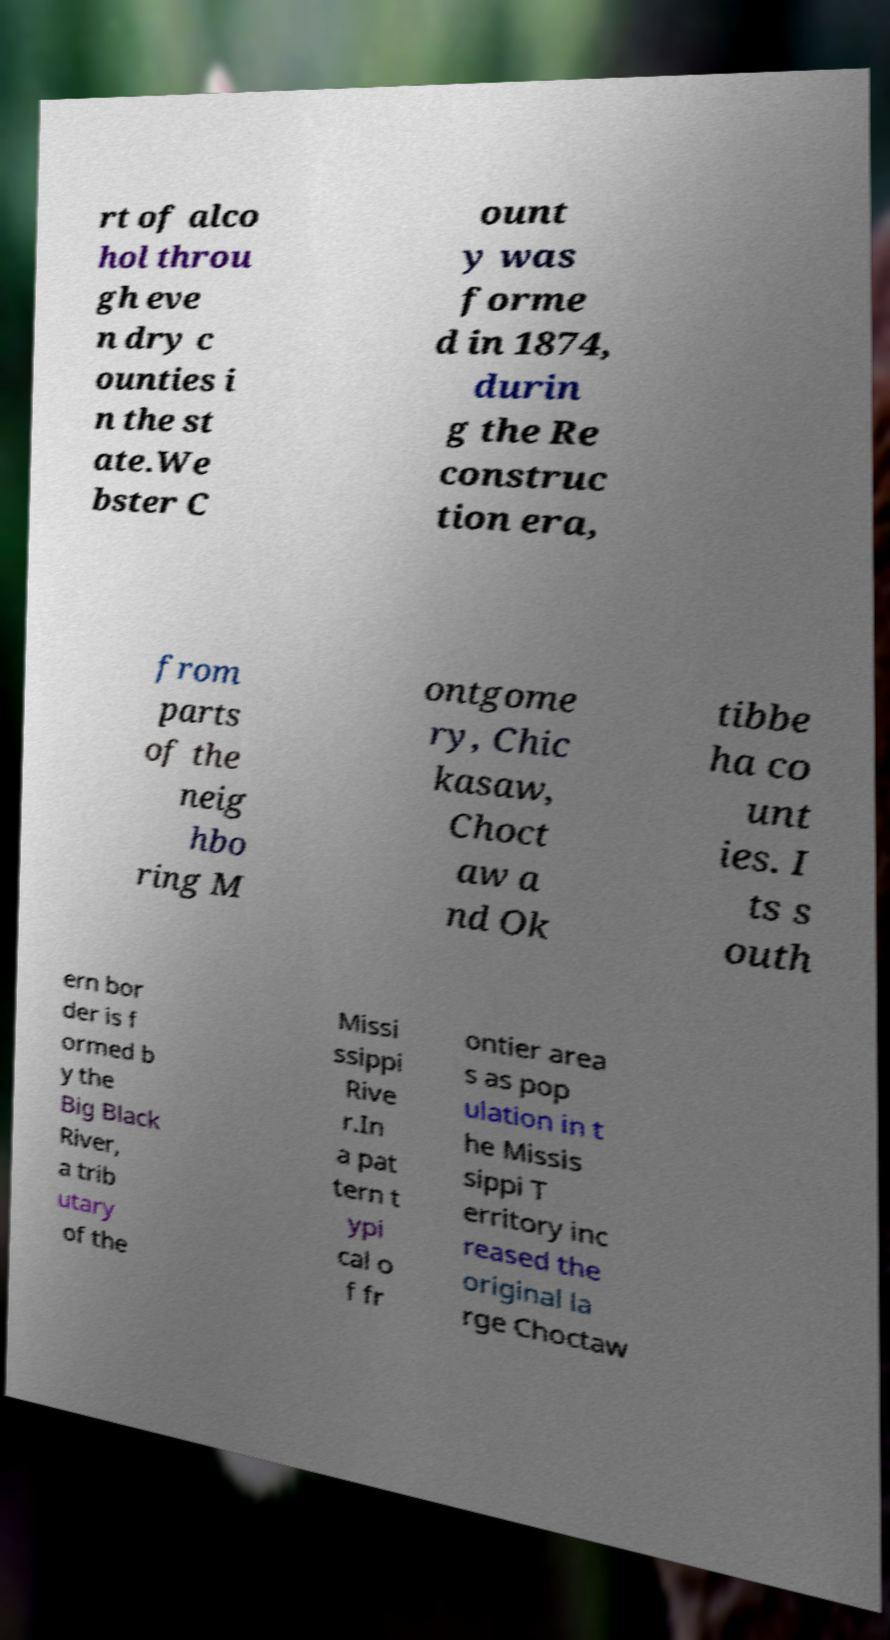Can you read and provide the text displayed in the image?This photo seems to have some interesting text. Can you extract and type it out for me? rt of alco hol throu gh eve n dry c ounties i n the st ate.We bster C ount y was forme d in 1874, durin g the Re construc tion era, from parts of the neig hbo ring M ontgome ry, Chic kasaw, Choct aw a nd Ok tibbe ha co unt ies. I ts s outh ern bor der is f ormed b y the Big Black River, a trib utary of the Missi ssippi Rive r.In a pat tern t ypi cal o f fr ontier area s as pop ulation in t he Missis sippi T erritory inc reased the original la rge Choctaw 